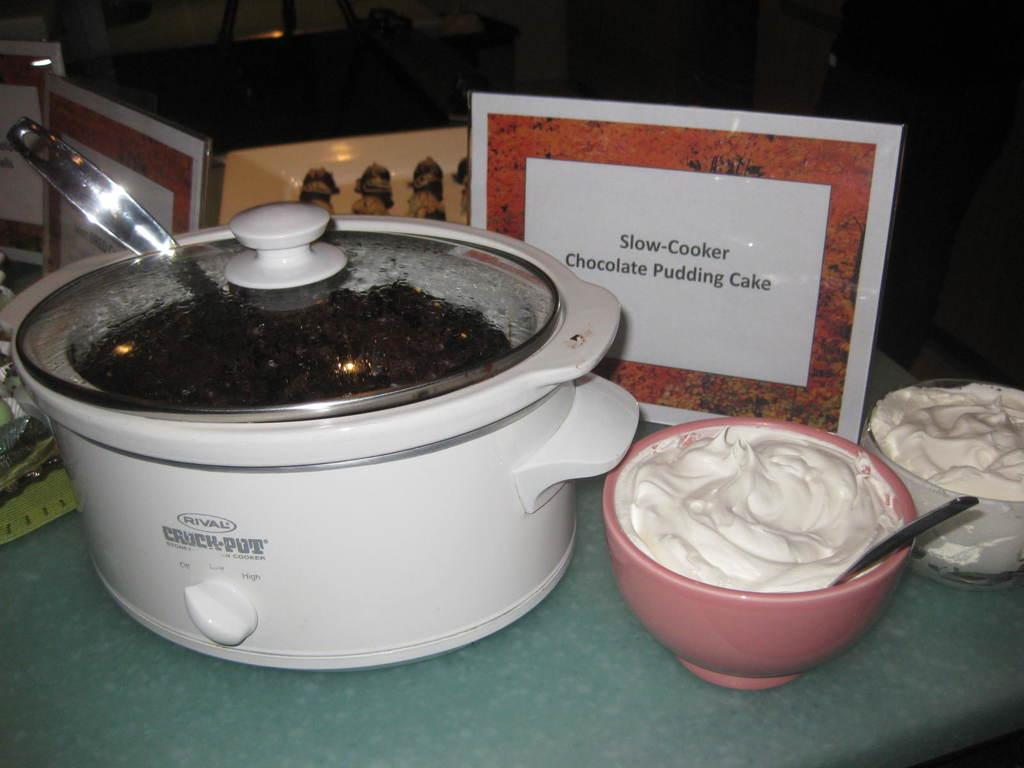<image>
Share a concise interpretation of the image provided. All of the components for a slow cooker, chocolate pudding cake are sitting on display in front of a sign labeling it. 